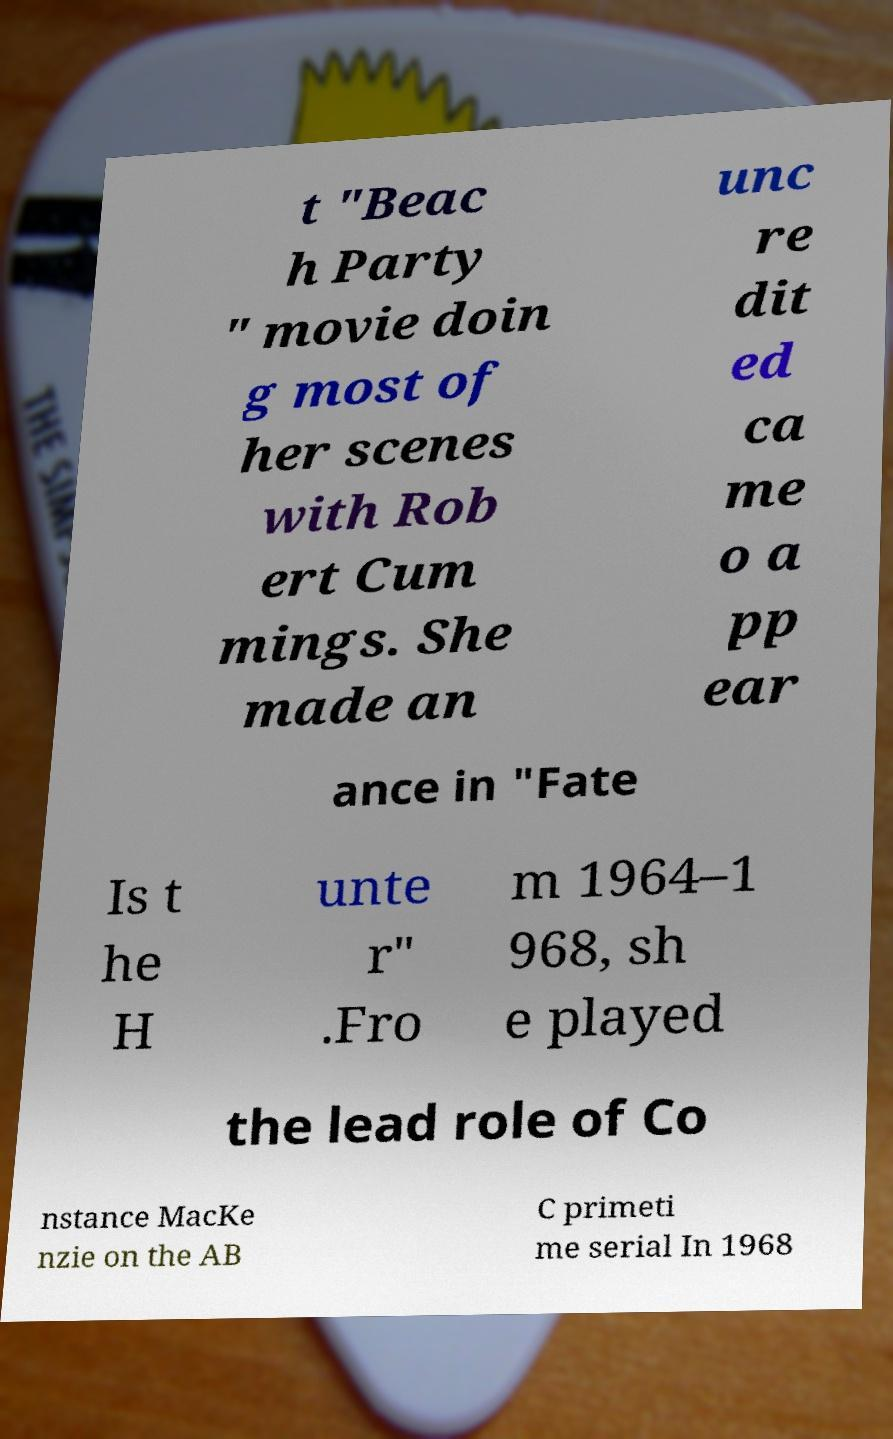What messages or text are displayed in this image? I need them in a readable, typed format. t "Beac h Party " movie doin g most of her scenes with Rob ert Cum mings. She made an unc re dit ed ca me o a pp ear ance in "Fate Is t he H unte r" .Fro m 1964–1 968, sh e played the lead role of Co nstance MacKe nzie on the AB C primeti me serial In 1968 